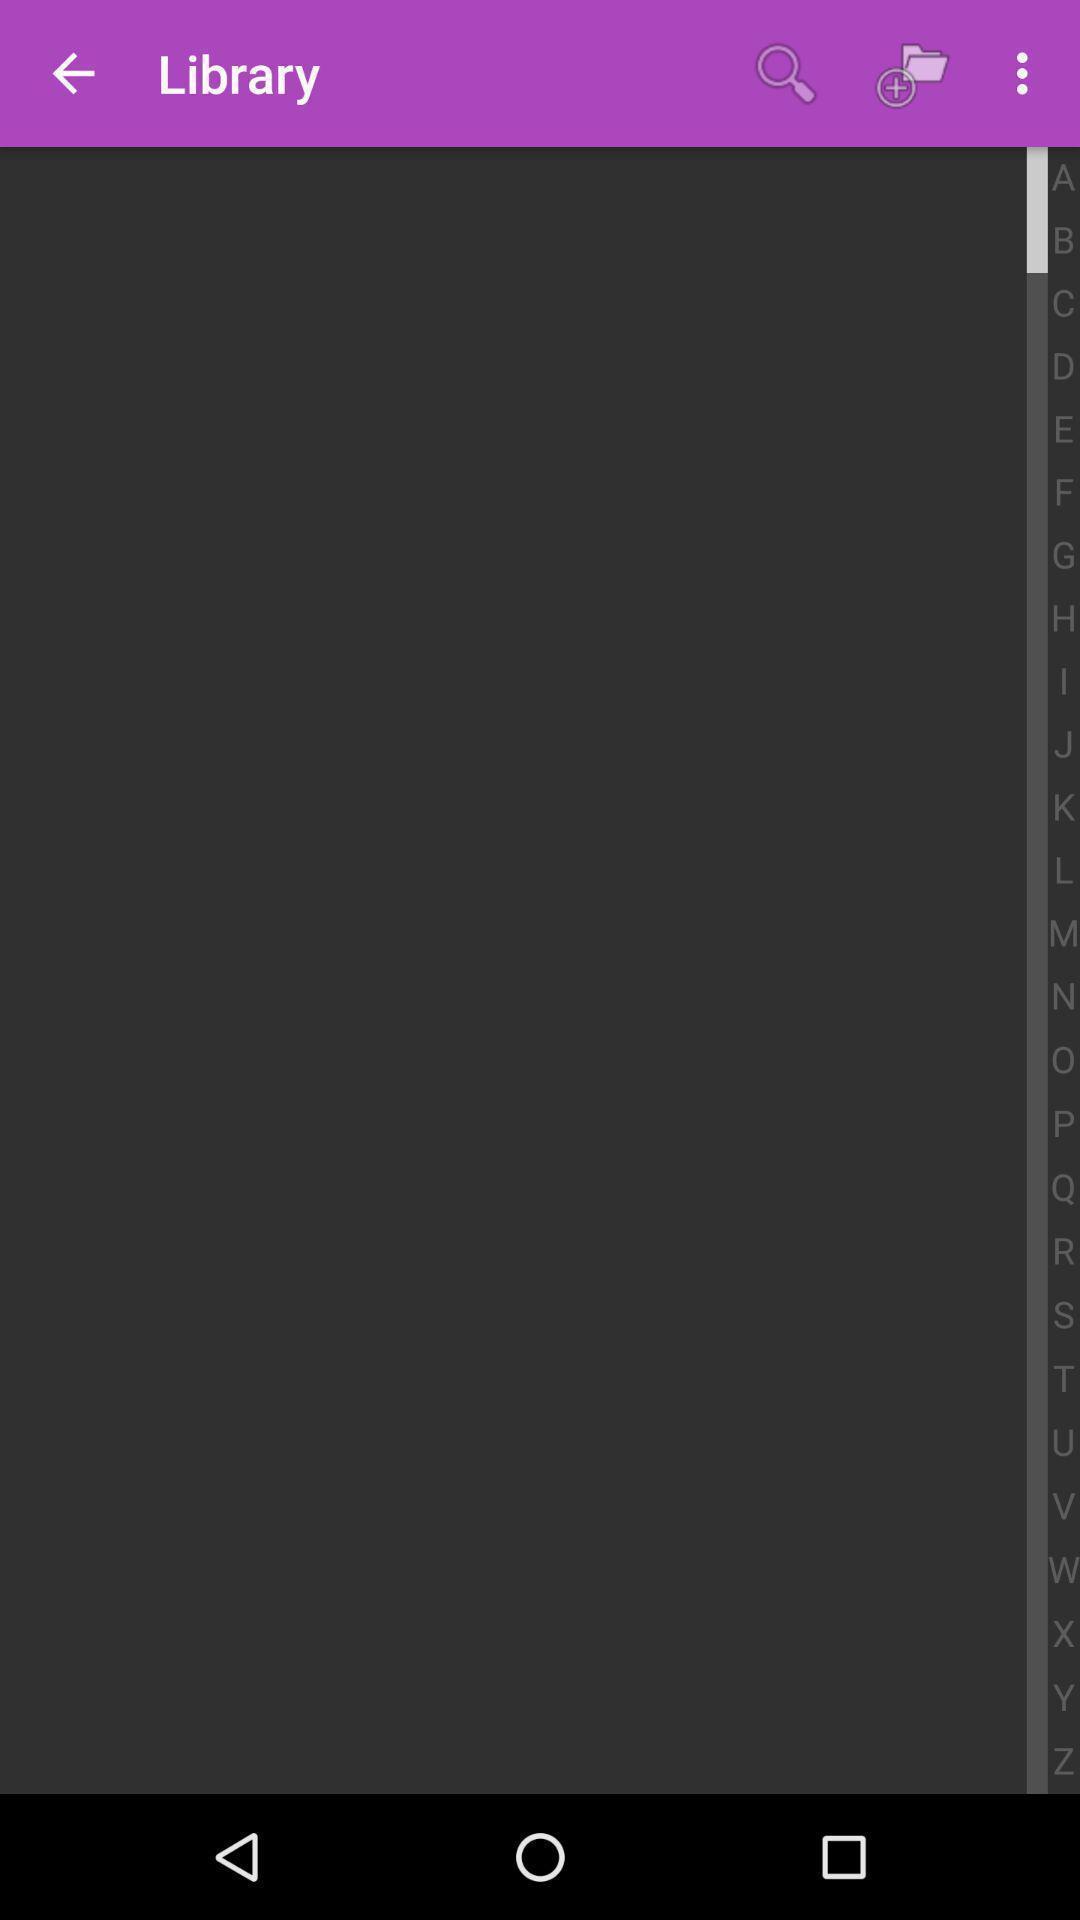Tell me about the visual elements in this screen capture. Search option showing for an library. 